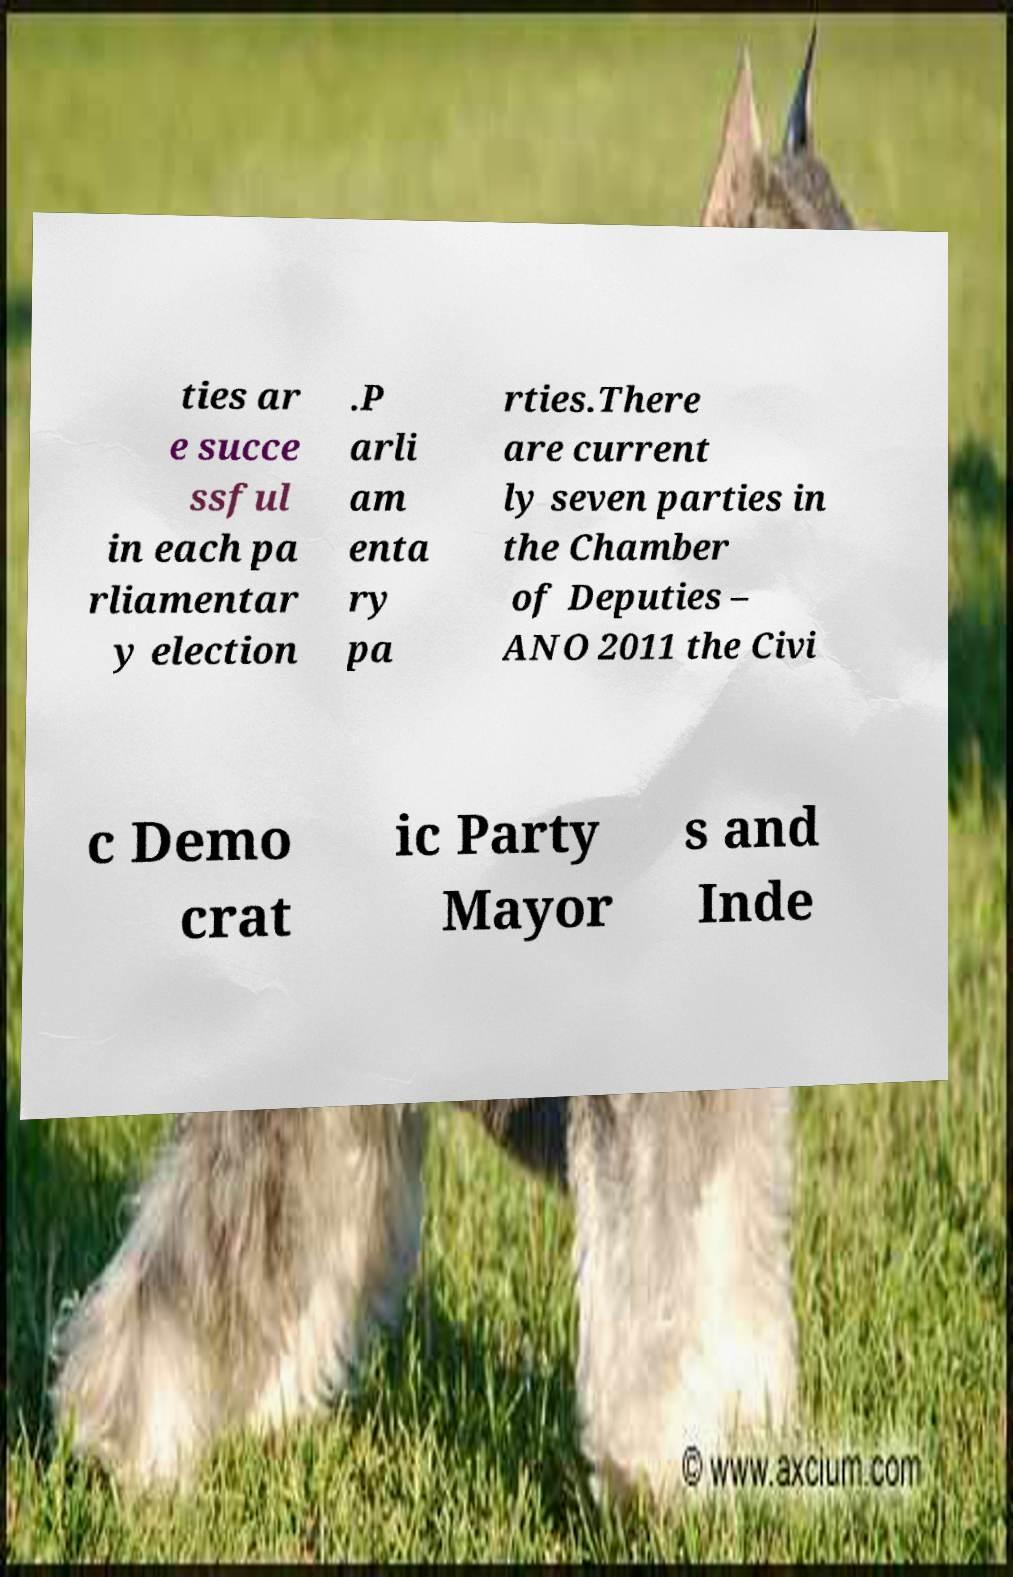I need the written content from this picture converted into text. Can you do that? ties ar e succe ssful in each pa rliamentar y election .P arli am enta ry pa rties.There are current ly seven parties in the Chamber of Deputies – ANO 2011 the Civi c Demo crat ic Party Mayor s and Inde 